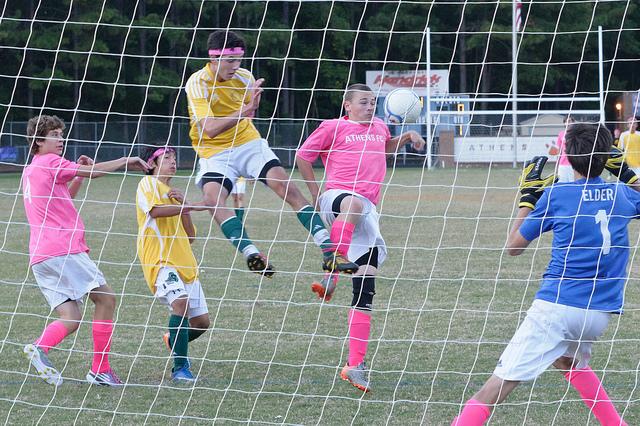Is the guy in the blue shirt a goalkeeper?
Give a very brief answer. Yes. Why are there squares?
Concise answer only. Net. What color shirt is the person jumping in the air wearing?
Keep it brief. Yellow. 